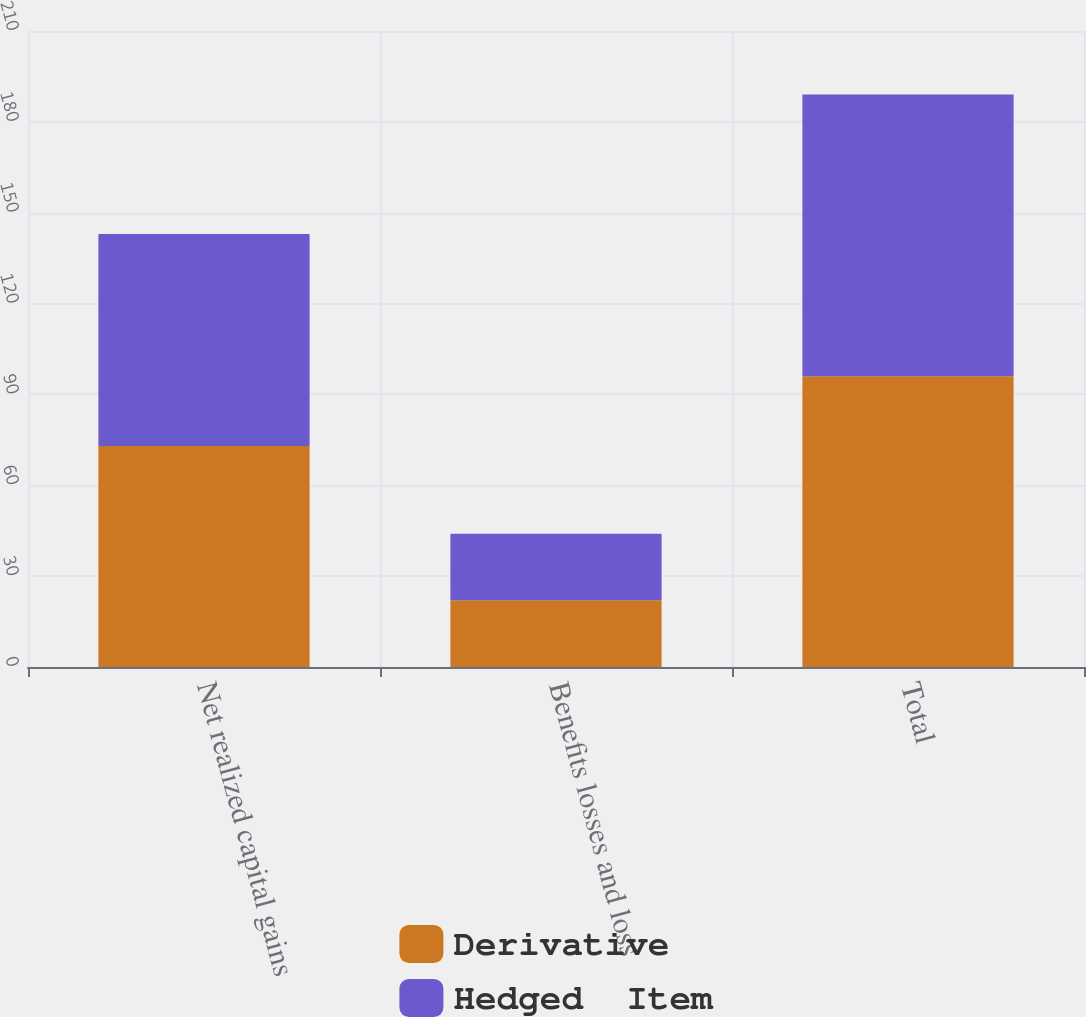<chart> <loc_0><loc_0><loc_500><loc_500><stacked_bar_chart><ecel><fcel>Net realized capital gains<fcel>Benefits losses and loss<fcel>Total<nl><fcel>Derivative<fcel>73<fcel>22<fcel>96<nl><fcel>Hedged  Item<fcel>70<fcel>22<fcel>93<nl></chart> 